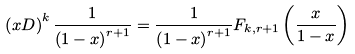Convert formula to latex. <formula><loc_0><loc_0><loc_500><loc_500>\left ( x D \right ) ^ { k } \frac { 1 } { \left ( 1 - x \right ) ^ { r + 1 } } = \frac { 1 } { \left ( 1 - x \right ) ^ { r + 1 } } F _ { k , r + 1 } \left ( \frac { x } { 1 - x } \right )</formula> 